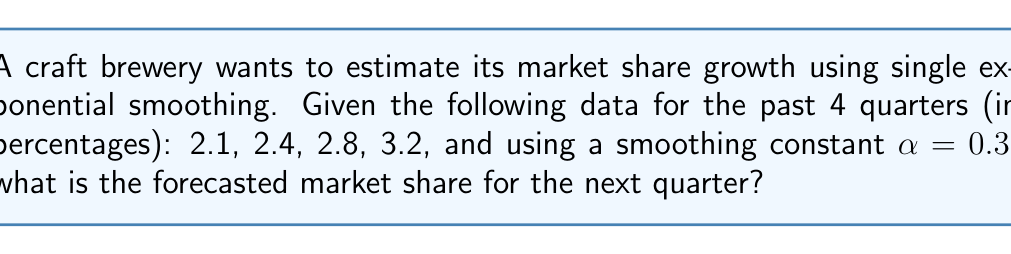What is the answer to this math problem? To solve this problem using single exponential smoothing, we'll follow these steps:

1. The formula for single exponential smoothing is:
   $$F_{t+1} = αY_t + (1-α)F_t$$
   Where:
   $F_{t+1}$ is the forecast for the next period
   $α$ is the smoothing constant (0.3 in this case)
   $Y_t$ is the actual value for the current period
   $F_t$ is the forecast for the current period

2. We start by setting the initial forecast ($F_1$) equal to the first actual value:
   $F_1 = 2.1$

3. Now we calculate the forecasts for each period:

   For t = 2:
   $$F_2 = 0.3(2.1) + 0.7(2.1) = 2.1$$

   For t = 3:
   $$F_3 = 0.3(2.4) + 0.7(2.1) = 2.19$$

   For t = 4:
   $$F_4 = 0.3(2.8) + 0.7(2.19) = 2.373$$

4. Finally, we calculate the forecast for the next quarter (t = 5):
   $$F_5 = 0.3(3.2) + 0.7(2.373) = 2.6211$$

5. Rounding to two decimal places, we get 2.62%.
Answer: 2.62% 